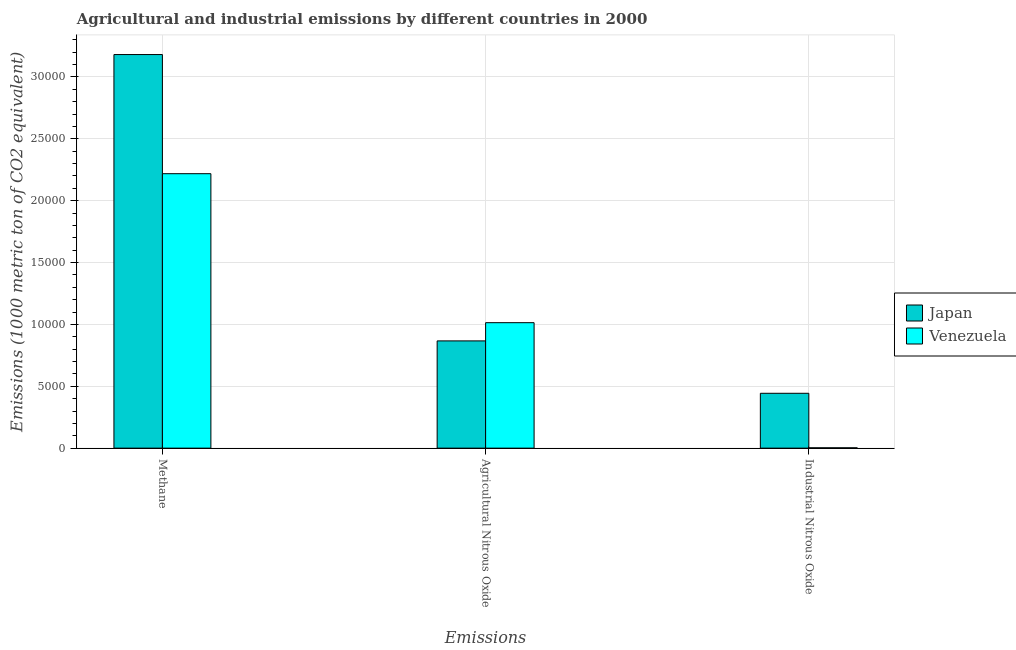Are the number of bars on each tick of the X-axis equal?
Your answer should be very brief. Yes. How many bars are there on the 1st tick from the right?
Give a very brief answer. 2. What is the label of the 2nd group of bars from the left?
Offer a very short reply. Agricultural Nitrous Oxide. What is the amount of industrial nitrous oxide emissions in Japan?
Provide a succinct answer. 4433.9. Across all countries, what is the maximum amount of agricultural nitrous oxide emissions?
Ensure brevity in your answer.  1.01e+04. Across all countries, what is the minimum amount of methane emissions?
Your response must be concise. 2.22e+04. In which country was the amount of industrial nitrous oxide emissions maximum?
Provide a short and direct response. Japan. In which country was the amount of methane emissions minimum?
Keep it short and to the point. Venezuela. What is the total amount of methane emissions in the graph?
Provide a short and direct response. 5.40e+04. What is the difference between the amount of industrial nitrous oxide emissions in Venezuela and that in Japan?
Your response must be concise. -4406. What is the difference between the amount of agricultural nitrous oxide emissions in Venezuela and the amount of industrial nitrous oxide emissions in Japan?
Ensure brevity in your answer.  5705.7. What is the average amount of agricultural nitrous oxide emissions per country?
Keep it short and to the point. 9403.4. What is the difference between the amount of industrial nitrous oxide emissions and amount of agricultural nitrous oxide emissions in Japan?
Make the answer very short. -4233.3. What is the ratio of the amount of industrial nitrous oxide emissions in Japan to that in Venezuela?
Offer a very short reply. 158.92. Is the difference between the amount of methane emissions in Venezuela and Japan greater than the difference between the amount of industrial nitrous oxide emissions in Venezuela and Japan?
Your answer should be very brief. No. What is the difference between the highest and the second highest amount of methane emissions?
Keep it short and to the point. 9628.2. What is the difference between the highest and the lowest amount of methane emissions?
Provide a succinct answer. 9628.2. In how many countries, is the amount of industrial nitrous oxide emissions greater than the average amount of industrial nitrous oxide emissions taken over all countries?
Give a very brief answer. 1. Is the sum of the amount of industrial nitrous oxide emissions in Japan and Venezuela greater than the maximum amount of methane emissions across all countries?
Your answer should be compact. No. What does the 1st bar from the left in Industrial Nitrous Oxide represents?
Your answer should be compact. Japan. What does the 1st bar from the right in Agricultural Nitrous Oxide represents?
Offer a very short reply. Venezuela. How many bars are there?
Your answer should be compact. 6. Are all the bars in the graph horizontal?
Provide a short and direct response. No. What is the difference between two consecutive major ticks on the Y-axis?
Your answer should be very brief. 5000. Does the graph contain grids?
Keep it short and to the point. Yes. Where does the legend appear in the graph?
Offer a terse response. Center right. How many legend labels are there?
Provide a short and direct response. 2. What is the title of the graph?
Ensure brevity in your answer.  Agricultural and industrial emissions by different countries in 2000. Does "Dominican Republic" appear as one of the legend labels in the graph?
Offer a terse response. No. What is the label or title of the X-axis?
Provide a succinct answer. Emissions. What is the label or title of the Y-axis?
Your answer should be very brief. Emissions (1000 metric ton of CO2 equivalent). What is the Emissions (1000 metric ton of CO2 equivalent) in Japan in Methane?
Your answer should be very brief. 3.18e+04. What is the Emissions (1000 metric ton of CO2 equivalent) in Venezuela in Methane?
Your response must be concise. 2.22e+04. What is the Emissions (1000 metric ton of CO2 equivalent) of Japan in Agricultural Nitrous Oxide?
Offer a very short reply. 8667.2. What is the Emissions (1000 metric ton of CO2 equivalent) in Venezuela in Agricultural Nitrous Oxide?
Give a very brief answer. 1.01e+04. What is the Emissions (1000 metric ton of CO2 equivalent) in Japan in Industrial Nitrous Oxide?
Provide a short and direct response. 4433.9. What is the Emissions (1000 metric ton of CO2 equivalent) in Venezuela in Industrial Nitrous Oxide?
Offer a very short reply. 27.9. Across all Emissions, what is the maximum Emissions (1000 metric ton of CO2 equivalent) of Japan?
Your response must be concise. 3.18e+04. Across all Emissions, what is the maximum Emissions (1000 metric ton of CO2 equivalent) of Venezuela?
Offer a terse response. 2.22e+04. Across all Emissions, what is the minimum Emissions (1000 metric ton of CO2 equivalent) in Japan?
Ensure brevity in your answer.  4433.9. Across all Emissions, what is the minimum Emissions (1000 metric ton of CO2 equivalent) in Venezuela?
Keep it short and to the point. 27.9. What is the total Emissions (1000 metric ton of CO2 equivalent) of Japan in the graph?
Give a very brief answer. 4.49e+04. What is the total Emissions (1000 metric ton of CO2 equivalent) in Venezuela in the graph?
Provide a succinct answer. 3.23e+04. What is the difference between the Emissions (1000 metric ton of CO2 equivalent) in Japan in Methane and that in Agricultural Nitrous Oxide?
Offer a very short reply. 2.31e+04. What is the difference between the Emissions (1000 metric ton of CO2 equivalent) in Venezuela in Methane and that in Agricultural Nitrous Oxide?
Ensure brevity in your answer.  1.20e+04. What is the difference between the Emissions (1000 metric ton of CO2 equivalent) of Japan in Methane and that in Industrial Nitrous Oxide?
Give a very brief answer. 2.74e+04. What is the difference between the Emissions (1000 metric ton of CO2 equivalent) in Venezuela in Methane and that in Industrial Nitrous Oxide?
Provide a short and direct response. 2.22e+04. What is the difference between the Emissions (1000 metric ton of CO2 equivalent) in Japan in Agricultural Nitrous Oxide and that in Industrial Nitrous Oxide?
Your response must be concise. 4233.3. What is the difference between the Emissions (1000 metric ton of CO2 equivalent) of Venezuela in Agricultural Nitrous Oxide and that in Industrial Nitrous Oxide?
Offer a very short reply. 1.01e+04. What is the difference between the Emissions (1000 metric ton of CO2 equivalent) of Japan in Methane and the Emissions (1000 metric ton of CO2 equivalent) of Venezuela in Agricultural Nitrous Oxide?
Offer a very short reply. 2.17e+04. What is the difference between the Emissions (1000 metric ton of CO2 equivalent) of Japan in Methane and the Emissions (1000 metric ton of CO2 equivalent) of Venezuela in Industrial Nitrous Oxide?
Provide a short and direct response. 3.18e+04. What is the difference between the Emissions (1000 metric ton of CO2 equivalent) in Japan in Agricultural Nitrous Oxide and the Emissions (1000 metric ton of CO2 equivalent) in Venezuela in Industrial Nitrous Oxide?
Your answer should be very brief. 8639.3. What is the average Emissions (1000 metric ton of CO2 equivalent) of Japan per Emissions?
Provide a succinct answer. 1.50e+04. What is the average Emissions (1000 metric ton of CO2 equivalent) of Venezuela per Emissions?
Ensure brevity in your answer.  1.08e+04. What is the difference between the Emissions (1000 metric ton of CO2 equivalent) of Japan and Emissions (1000 metric ton of CO2 equivalent) of Venezuela in Methane?
Your answer should be very brief. 9628.2. What is the difference between the Emissions (1000 metric ton of CO2 equivalent) in Japan and Emissions (1000 metric ton of CO2 equivalent) in Venezuela in Agricultural Nitrous Oxide?
Your answer should be very brief. -1472.4. What is the difference between the Emissions (1000 metric ton of CO2 equivalent) of Japan and Emissions (1000 metric ton of CO2 equivalent) of Venezuela in Industrial Nitrous Oxide?
Keep it short and to the point. 4406. What is the ratio of the Emissions (1000 metric ton of CO2 equivalent) in Japan in Methane to that in Agricultural Nitrous Oxide?
Your response must be concise. 3.67. What is the ratio of the Emissions (1000 metric ton of CO2 equivalent) in Venezuela in Methane to that in Agricultural Nitrous Oxide?
Ensure brevity in your answer.  2.19. What is the ratio of the Emissions (1000 metric ton of CO2 equivalent) of Japan in Methane to that in Industrial Nitrous Oxide?
Your answer should be compact. 7.17. What is the ratio of the Emissions (1000 metric ton of CO2 equivalent) in Venezuela in Methane to that in Industrial Nitrous Oxide?
Your answer should be very brief. 795. What is the ratio of the Emissions (1000 metric ton of CO2 equivalent) of Japan in Agricultural Nitrous Oxide to that in Industrial Nitrous Oxide?
Your response must be concise. 1.95. What is the ratio of the Emissions (1000 metric ton of CO2 equivalent) of Venezuela in Agricultural Nitrous Oxide to that in Industrial Nitrous Oxide?
Your answer should be very brief. 363.43. What is the difference between the highest and the second highest Emissions (1000 metric ton of CO2 equivalent) of Japan?
Provide a short and direct response. 2.31e+04. What is the difference between the highest and the second highest Emissions (1000 metric ton of CO2 equivalent) in Venezuela?
Your response must be concise. 1.20e+04. What is the difference between the highest and the lowest Emissions (1000 metric ton of CO2 equivalent) in Japan?
Make the answer very short. 2.74e+04. What is the difference between the highest and the lowest Emissions (1000 metric ton of CO2 equivalent) of Venezuela?
Keep it short and to the point. 2.22e+04. 